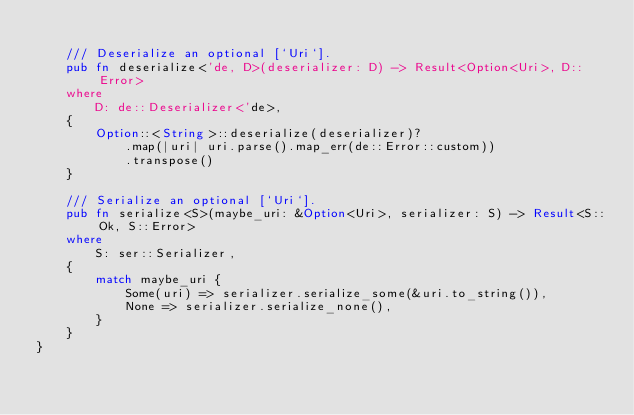Convert code to text. <code><loc_0><loc_0><loc_500><loc_500><_Rust_>
    /// Deserialize an optional [`Uri`].
    pub fn deserialize<'de, D>(deserializer: D) -> Result<Option<Uri>, D::Error>
    where
        D: de::Deserializer<'de>,
    {
        Option::<String>::deserialize(deserializer)?
            .map(|uri| uri.parse().map_err(de::Error::custom))
            .transpose()
    }

    /// Serialize an optional [`Uri`].
    pub fn serialize<S>(maybe_uri: &Option<Uri>, serializer: S) -> Result<S::Ok, S::Error>
    where
        S: ser::Serializer,
    {
        match maybe_uri {
            Some(uri) => serializer.serialize_some(&uri.to_string()),
            None => serializer.serialize_none(),
        }
    }
}
</code> 